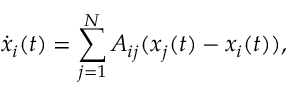Convert formula to latex. <formula><loc_0><loc_0><loc_500><loc_500>\dot { x } _ { i } ( t ) = \sum _ { j = 1 } ^ { N } A _ { i j } ( x _ { j } ( t ) - x _ { i } ( t ) ) ,</formula> 